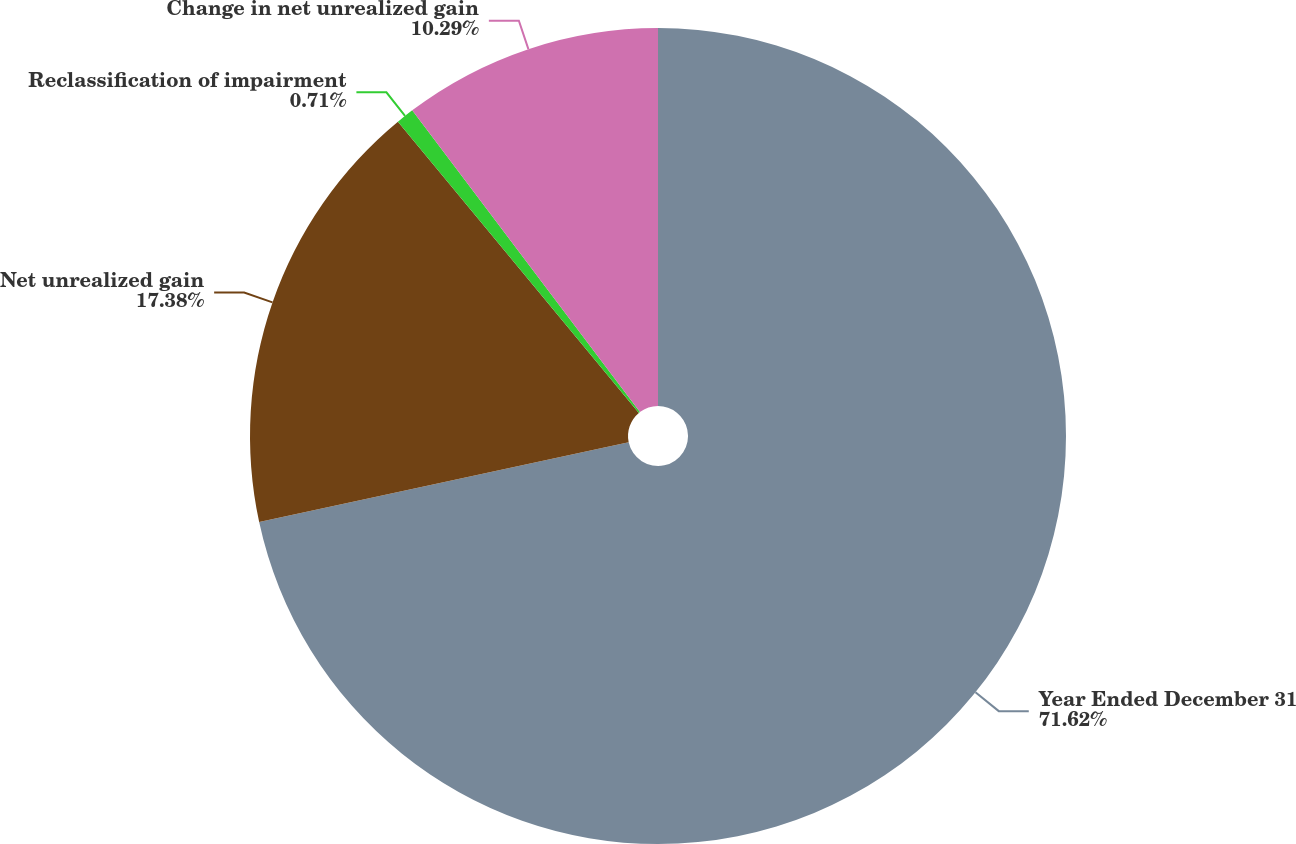Convert chart to OTSL. <chart><loc_0><loc_0><loc_500><loc_500><pie_chart><fcel>Year Ended December 31<fcel>Net unrealized gain<fcel>Reclassification of impairment<fcel>Change in net unrealized gain<nl><fcel>71.62%<fcel>17.38%<fcel>0.71%<fcel>10.29%<nl></chart> 